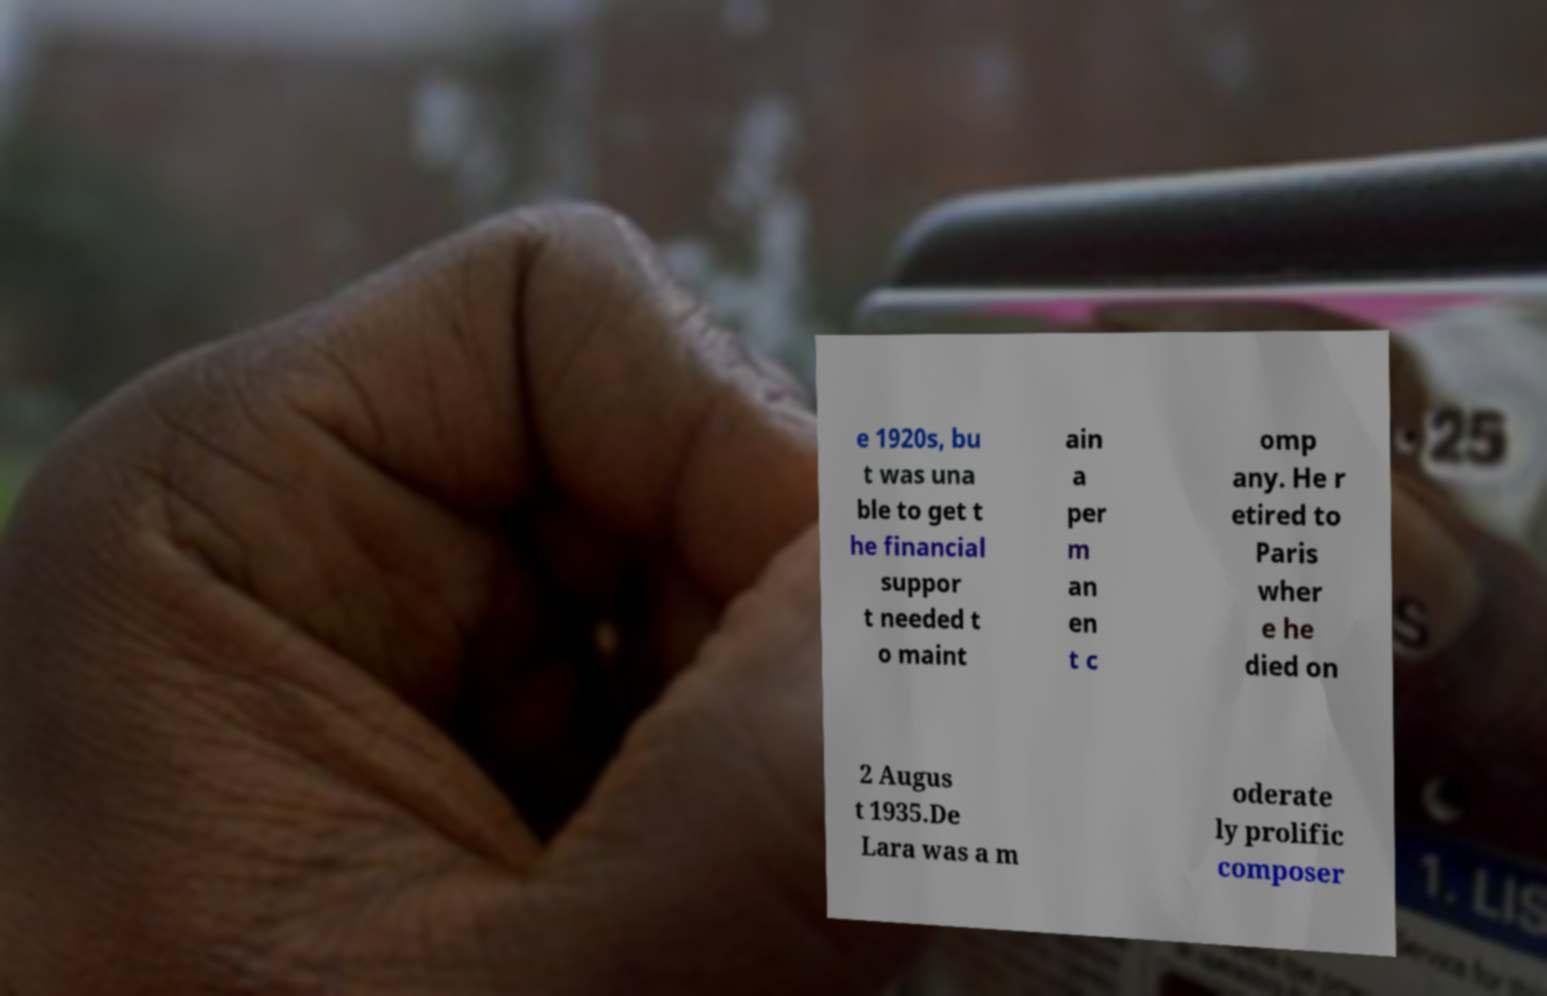Please identify and transcribe the text found in this image. e 1920s, bu t was una ble to get t he financial suppor t needed t o maint ain a per m an en t c omp any. He r etired to Paris wher e he died on 2 Augus t 1935.De Lara was a m oderate ly prolific composer 